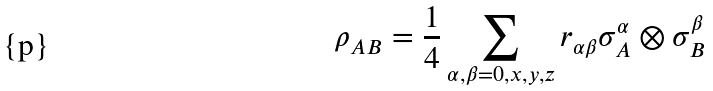<formula> <loc_0><loc_0><loc_500><loc_500>\rho _ { A B } = \frac { 1 } { 4 } \sum _ { \alpha , \beta = 0 , x , y , z } r _ { \alpha \beta } \sigma _ { A } ^ { \alpha } \otimes \sigma _ { B } ^ { \beta }</formula> 